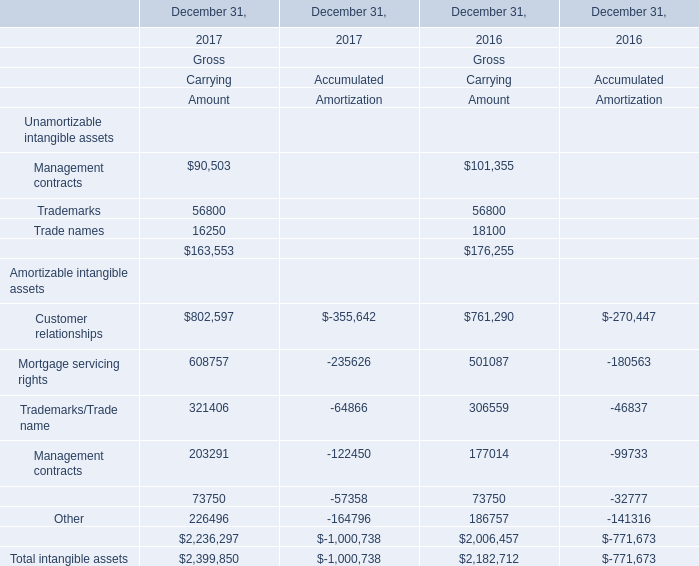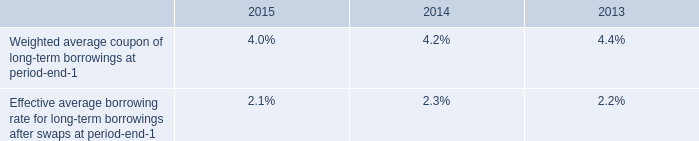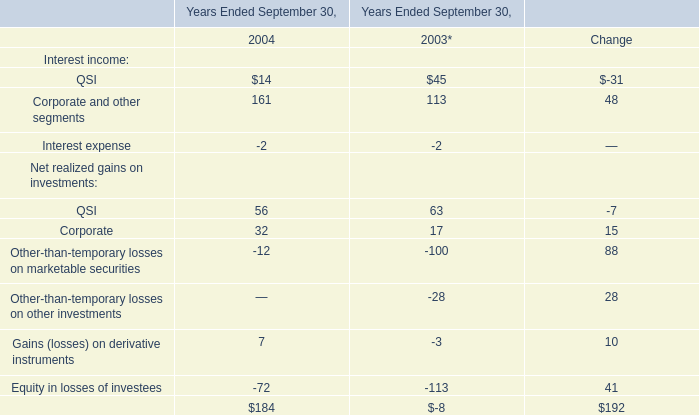What's the sum of all Gross that are positive in 2017? (in thousand) 
Computations: (163553 + 2236297)
Answer: 2399850.0. 